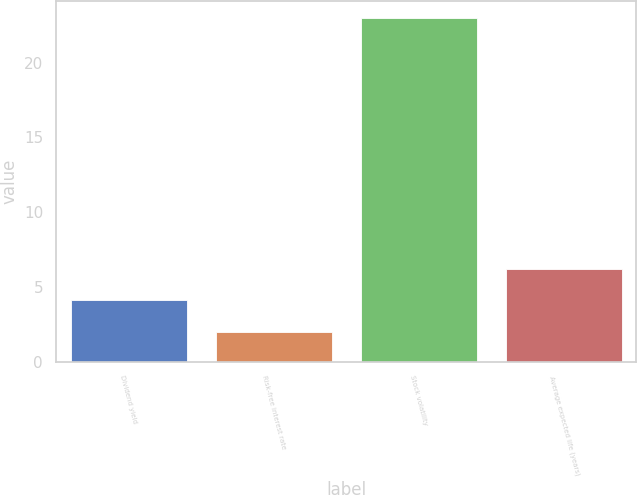<chart> <loc_0><loc_0><loc_500><loc_500><bar_chart><fcel>Dividend yield<fcel>Risk-free interest rate<fcel>Stock volatility<fcel>Average expected life (years)<nl><fcel>4.1<fcel>2<fcel>23<fcel>6.2<nl></chart> 